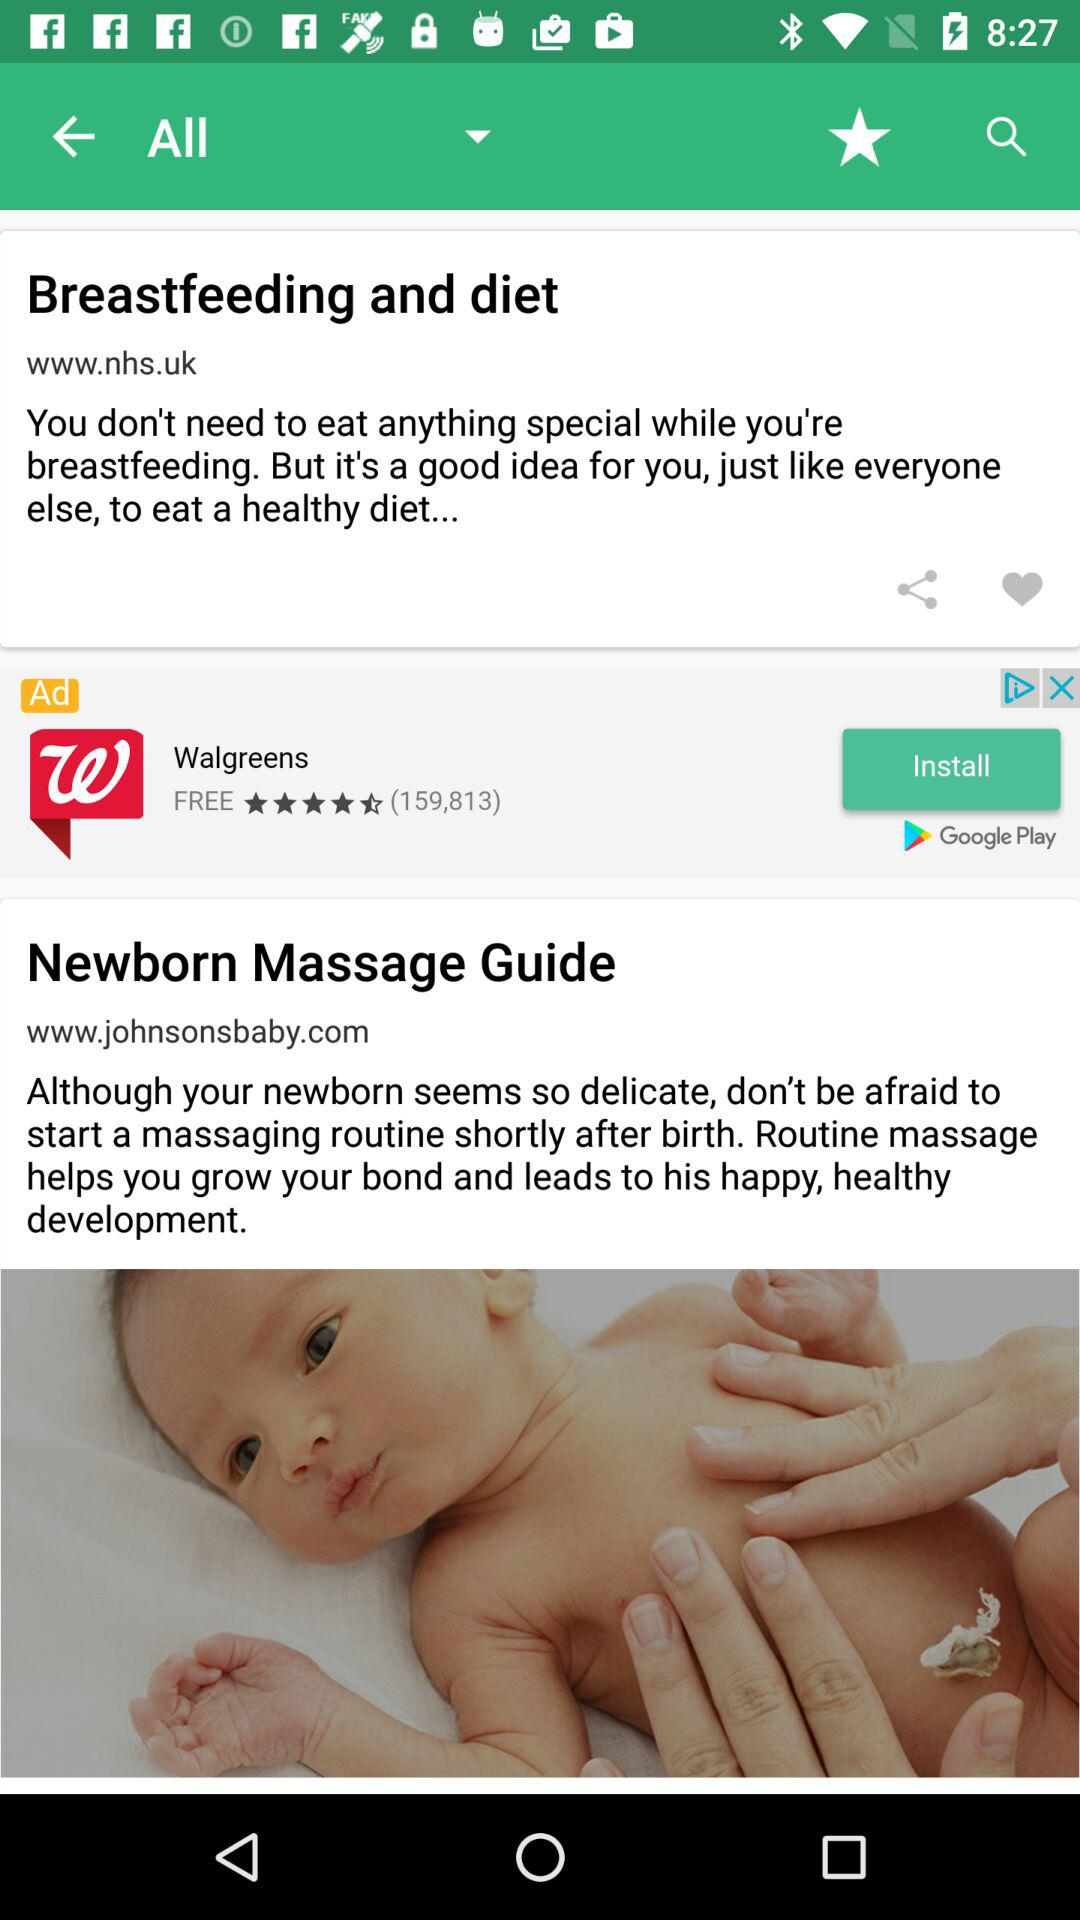When was "Newborn Massage Guide" uploaded?
When the provided information is insufficient, respond with <no answer>. <no answer> 